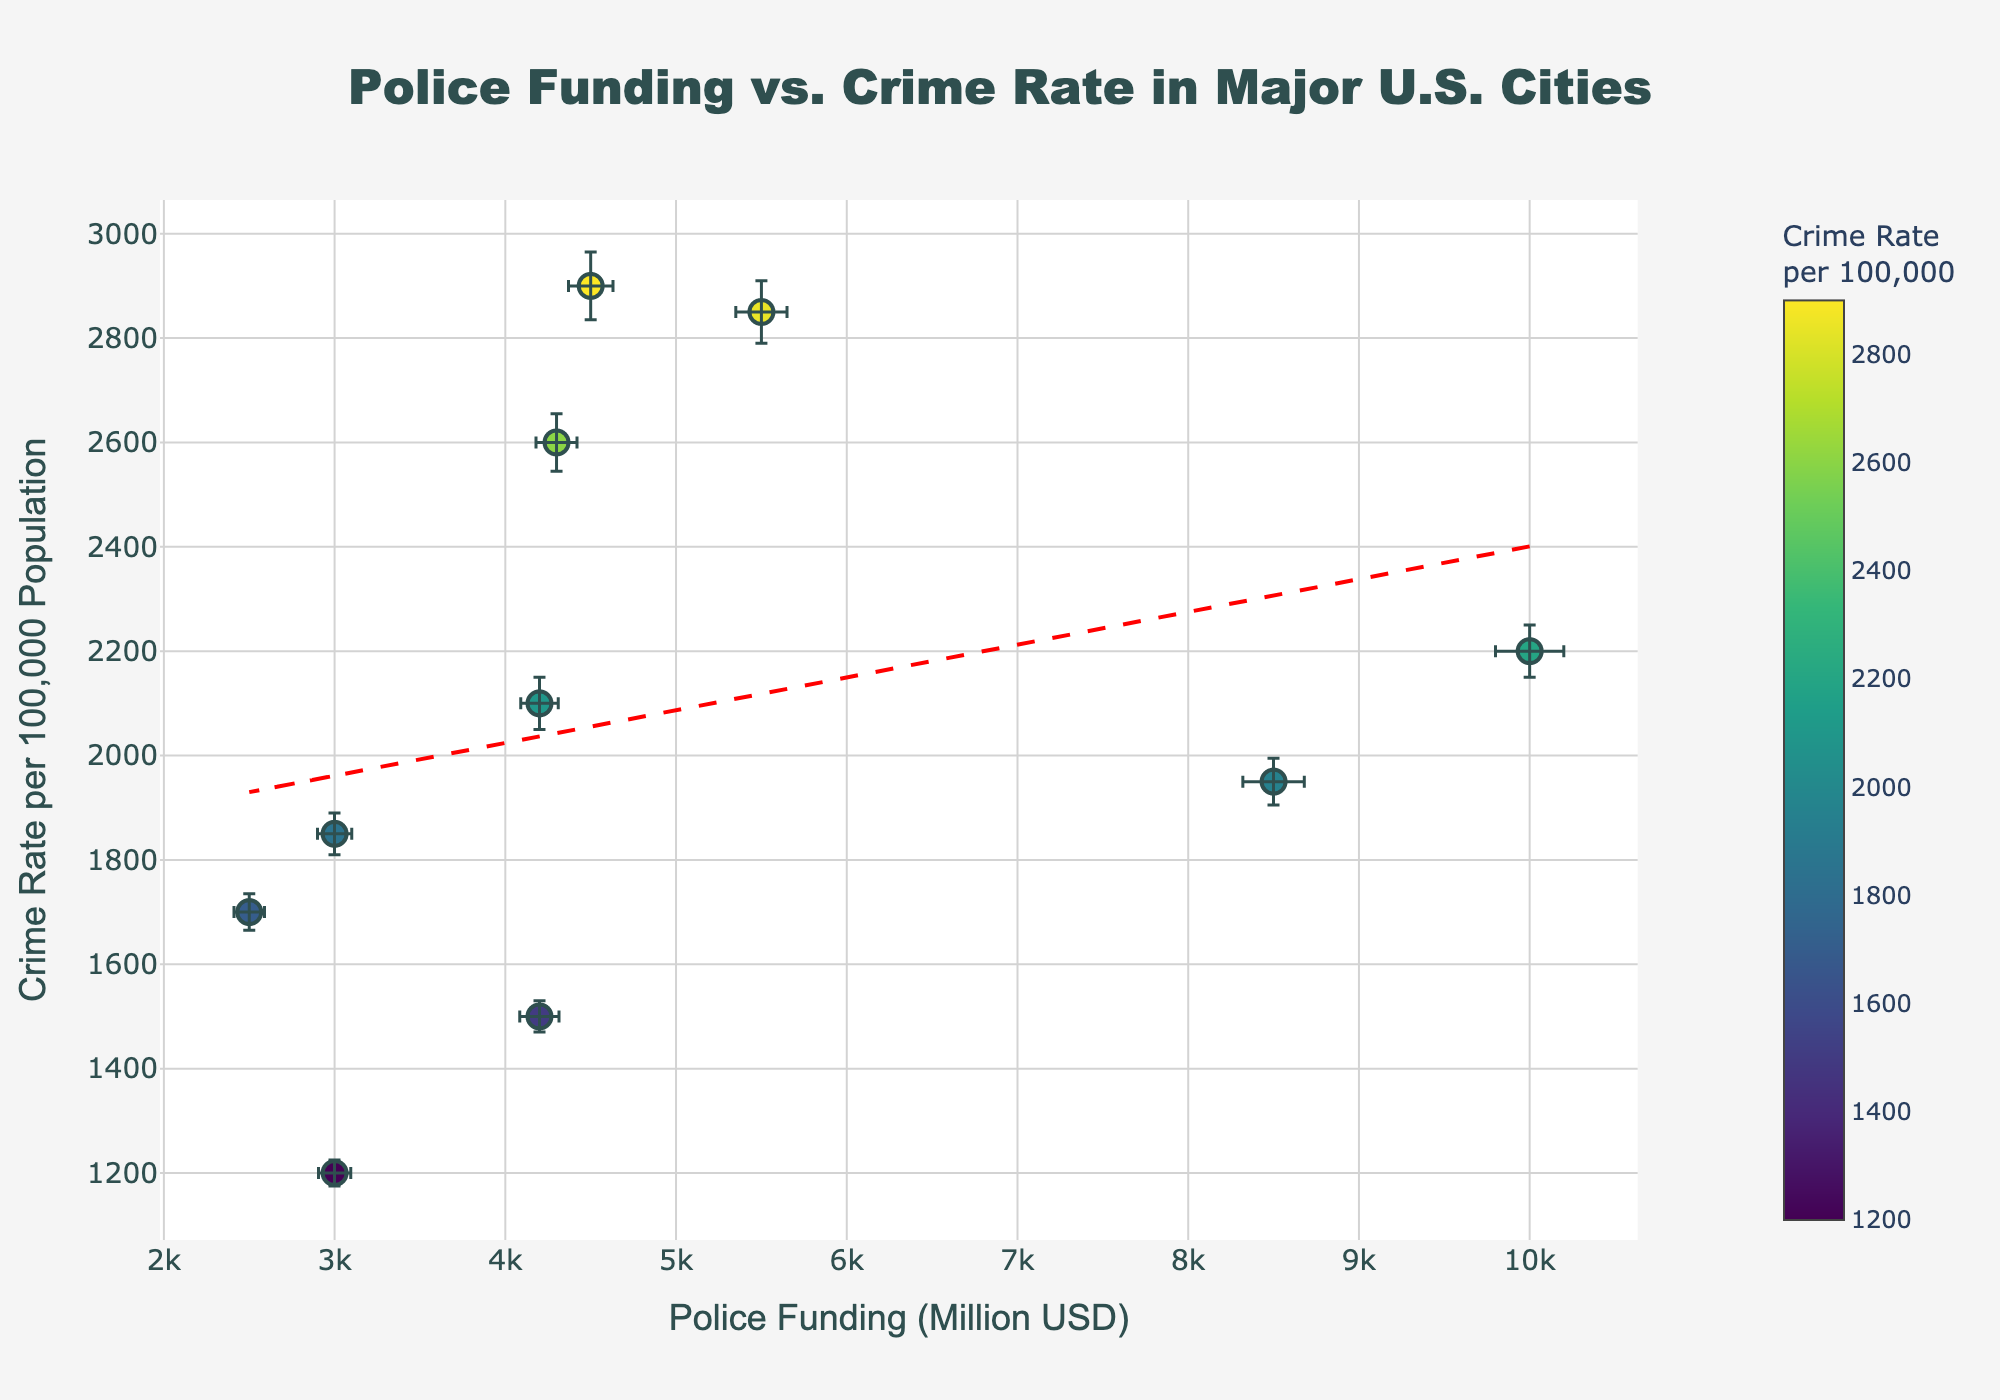What's the title of the figure? The title is typically located at the top of the figure. It is provided in a larger and bold font for easy visibility.
Answer: Police Funding vs. Crime Rate in Major U.S. Cities How many data points (cities) are shown in the scatter plot? Each city is represented by a marker on the plot. By counting all the markers, we can determine the number of data points.
Answer: 10 Which city has the highest crime rate? By comparing the y-values (Crime Rate per 100,000 Population) of all the markers, the city with the highest y-value has the highest crime rate.
Answer: Houston Which city has the lowest police funding? By comparing the x-values (Police Funding in Million USD) of all the markers, the city with the lowest x-value has the lowest police funding.
Answer: San Antonio Which city is represented by the marker with the largest error margin in crime rate? We need to identify the marker with the largest error bar extending vertically, which represents the crime rate's error margin.
Answer: Houston Is there a general trend between police funding and crime rate? By observing the trendline added to the plot, which is based on a polynomial fit, we can identify the slope's direction to understand if the trend is increasing or decreasing.
Answer: Decreasing trend What is the crime rate of New York City, and how does it compare to Los Angeles? Look at the y-values for New York City and Los Angeles markers and compare them to see which is higher or lower.
Answer: New York City's crime rate is 2200, which is higher than Los Angeles's 1950 What is the approximate slope of the trendline? The trendline slope can be estimated from the equation provided by the polyfit function or visually observing the angle of the line.
Answer: Approximately -0.3 (Note: This estimation can vary slightly based on the exact calculation) For cities with police funding between 4000 and 5000 million USD, which has the highest crime rate? Look at the markers within the x-range of 4000 to 5000 and compare their y-values. Identify the marker with the highest y-value.
Answer: Houston What is the range of crime rates among the cities with the highest and lowest funding? Subtract the crime rate of the city with the lowest funding from that of the city with the highest funding. Compare y-values for precision.
Answer: 2900 - 1200 = 1700 